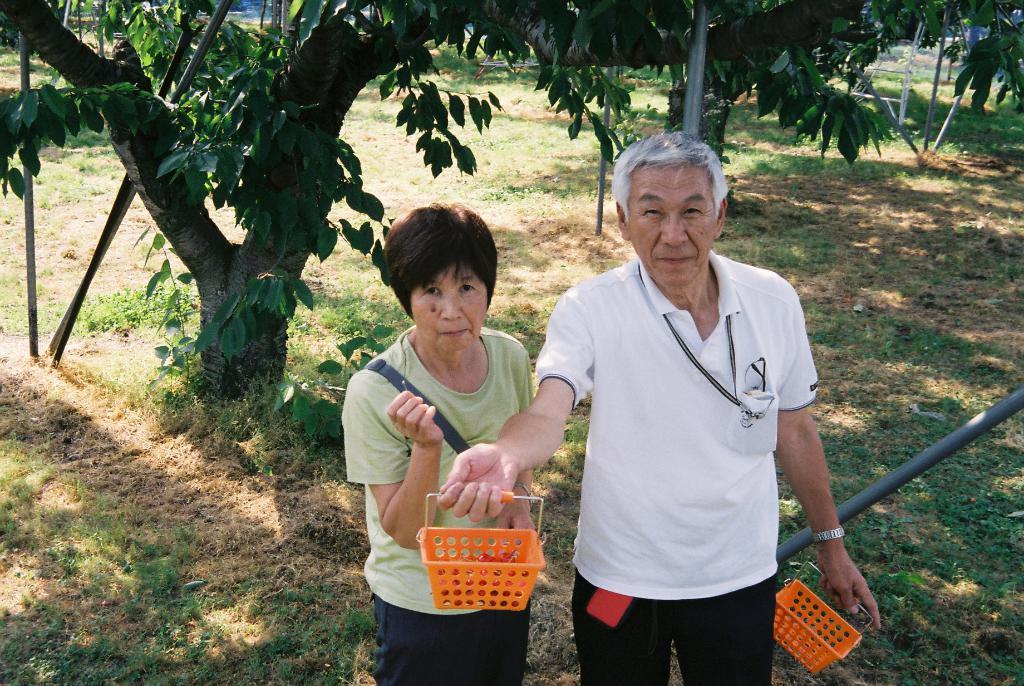Please provide a concise description of this image. In this image we can see a man and a woman standing on the ground. In that a man is holding the baskets. We can also see grass, some poles and trees. 